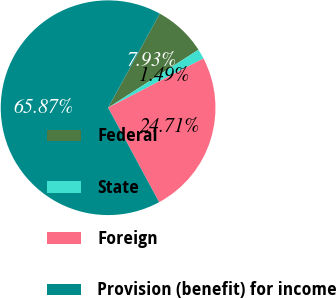<chart> <loc_0><loc_0><loc_500><loc_500><pie_chart><fcel>Federal<fcel>State<fcel>Foreign<fcel>Provision (benefit) for income<nl><fcel>7.93%<fcel>1.49%<fcel>24.71%<fcel>65.87%<nl></chart> 